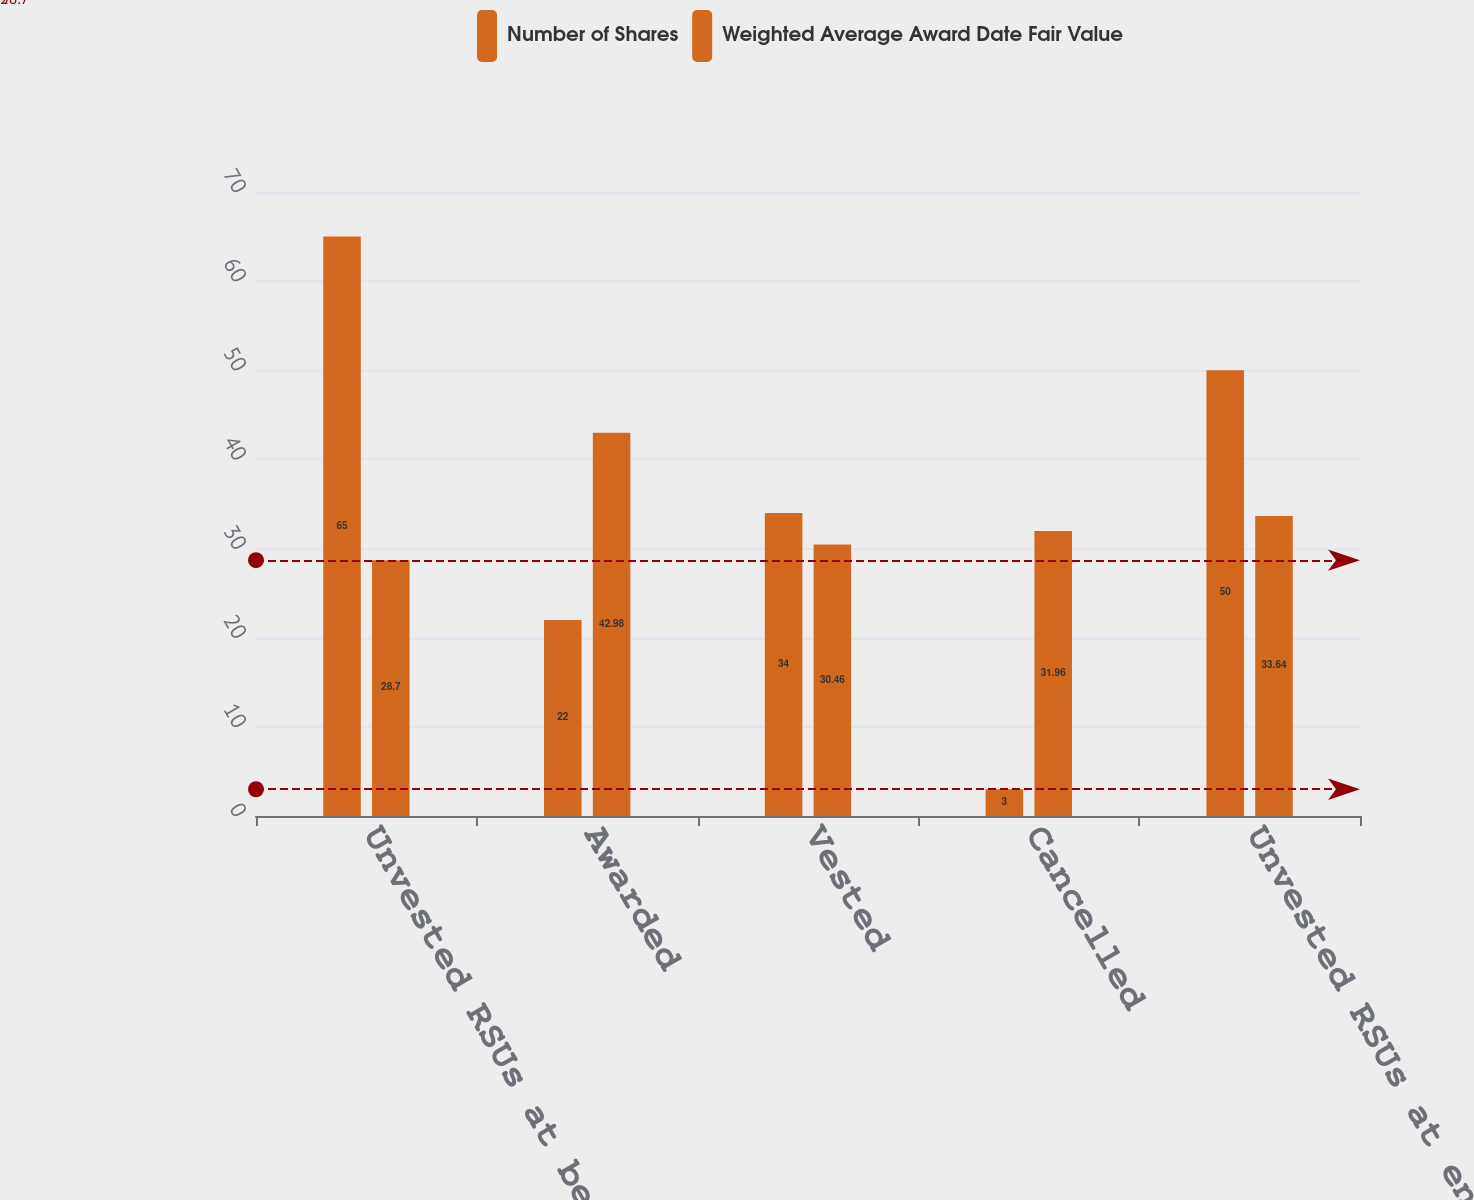Convert chart. <chart><loc_0><loc_0><loc_500><loc_500><stacked_bar_chart><ecel><fcel>Unvested RSUs at beginning of<fcel>Awarded<fcel>Vested<fcel>Cancelled<fcel>Unvested RSUs at end of period<nl><fcel>Number of Shares<fcel>65<fcel>22<fcel>34<fcel>3<fcel>50<nl><fcel>Weighted Average Award Date Fair Value<fcel>28.7<fcel>42.98<fcel>30.46<fcel>31.96<fcel>33.64<nl></chart> 